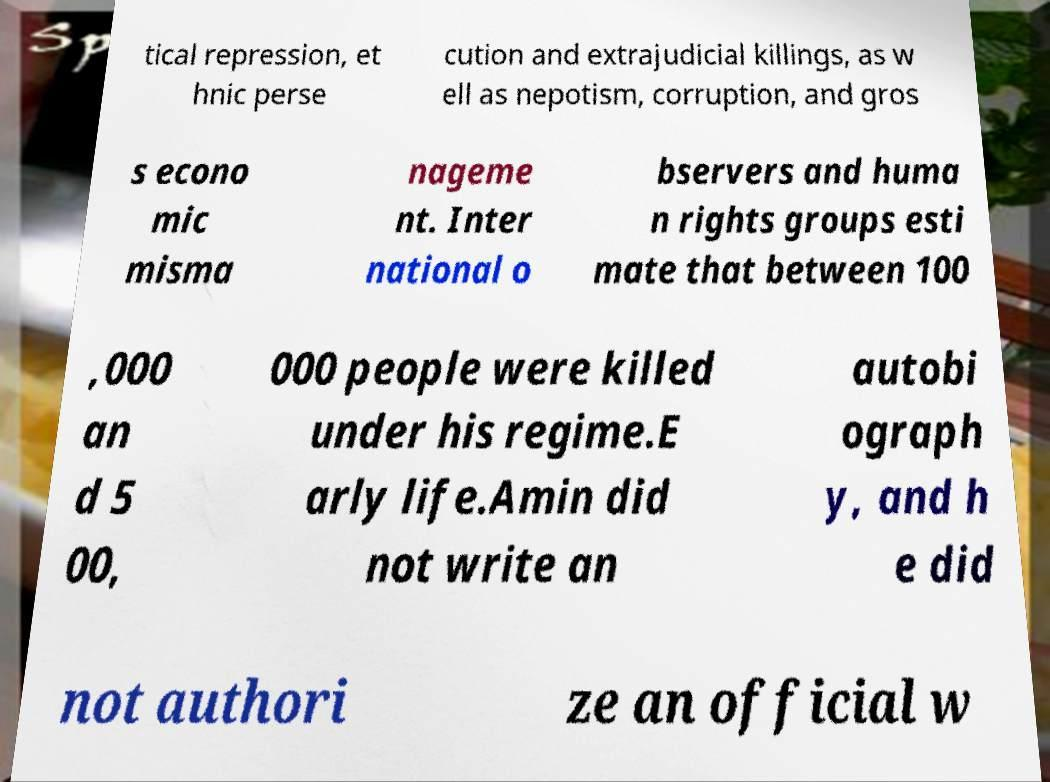What messages or text are displayed in this image? I need them in a readable, typed format. tical repression, et hnic perse cution and extrajudicial killings, as w ell as nepotism, corruption, and gros s econo mic misma nageme nt. Inter national o bservers and huma n rights groups esti mate that between 100 ,000 an d 5 00, 000 people were killed under his regime.E arly life.Amin did not write an autobi ograph y, and h e did not authori ze an official w 